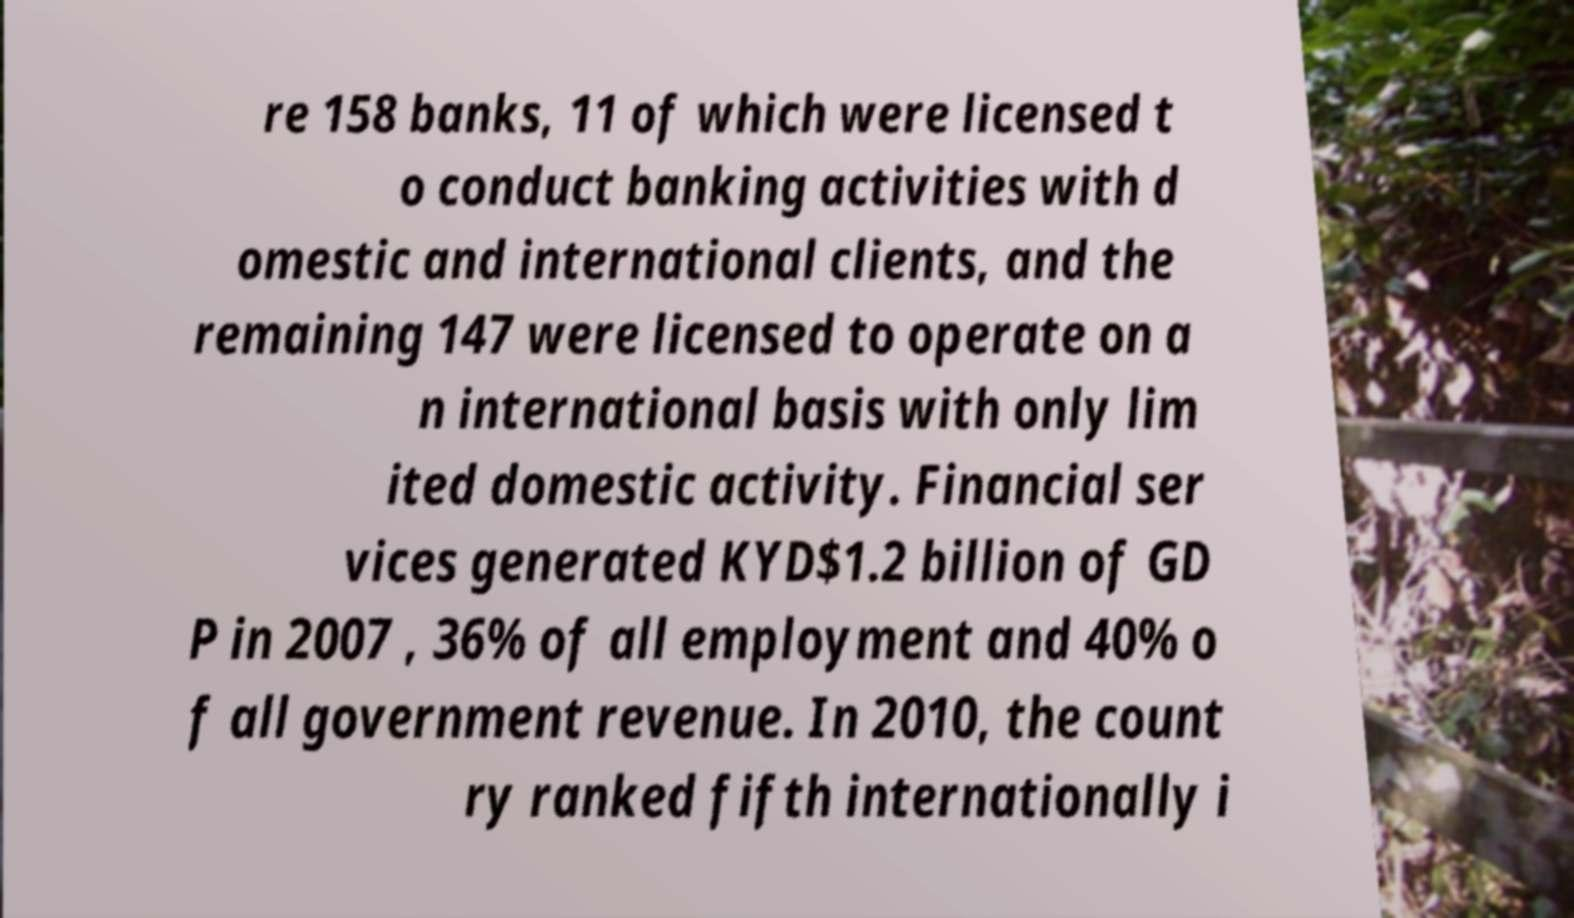Can you read and provide the text displayed in the image?This photo seems to have some interesting text. Can you extract and type it out for me? re 158 banks, 11 of which were licensed t o conduct banking activities with d omestic and international clients, and the remaining 147 were licensed to operate on a n international basis with only lim ited domestic activity. Financial ser vices generated KYD$1.2 billion of GD P in 2007 , 36% of all employment and 40% o f all government revenue. In 2010, the count ry ranked fifth internationally i 